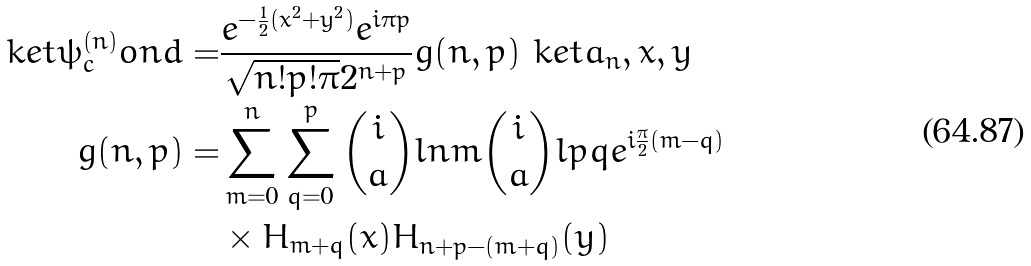Convert formula to latex. <formula><loc_0><loc_0><loc_500><loc_500>\ k e t { \psi ^ { ( n ) } _ { c } o n d } = & \frac { e ^ { - \frac { 1 } { 2 } ( x ^ { 2 } + y ^ { 2 } ) } e ^ { i \pi p } } { \sqrt { n ! p ! \pi } 2 ^ { n + p } } g ( n , p ) \ k e t { a _ { n } , x , y } \\ g ( n , p ) = & \sum _ { m = 0 } ^ { n } \sum _ { q = 0 } ^ { p } \binom { i } { a } l { n } { m } \binom { i } { a } l { p } { q } e ^ { i \frac { \pi } { 2 } ( m - q ) } \\ & \times H _ { m + q } ( x ) H _ { n + p - ( m + q ) } ( y )</formula> 